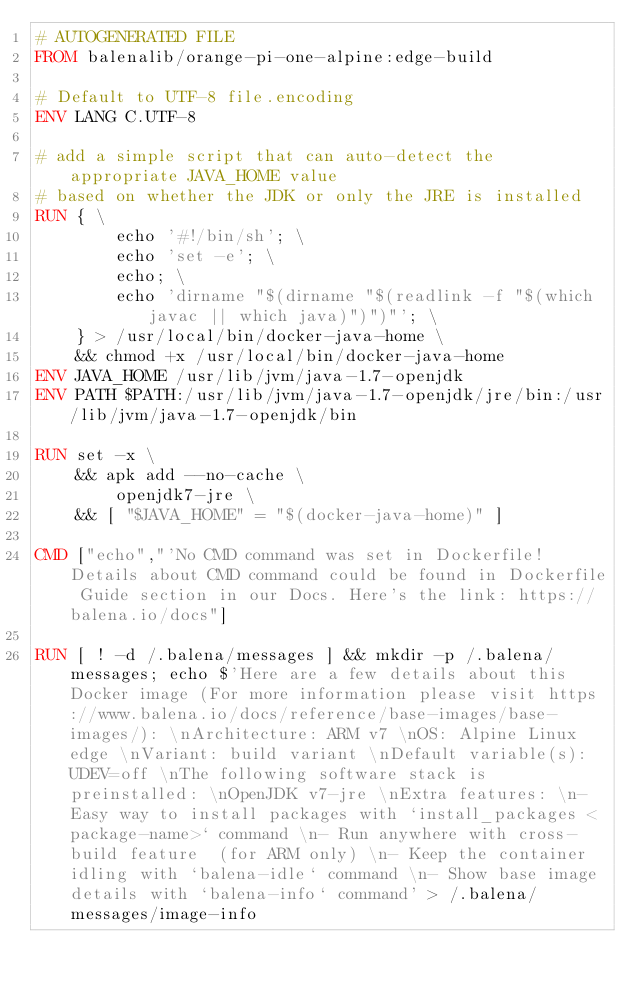Convert code to text. <code><loc_0><loc_0><loc_500><loc_500><_Dockerfile_># AUTOGENERATED FILE
FROM balenalib/orange-pi-one-alpine:edge-build

# Default to UTF-8 file.encoding
ENV LANG C.UTF-8

# add a simple script that can auto-detect the appropriate JAVA_HOME value
# based on whether the JDK or only the JRE is installed
RUN { \
		echo '#!/bin/sh'; \
		echo 'set -e'; \
		echo; \
		echo 'dirname "$(dirname "$(readlink -f "$(which javac || which java)")")"'; \
	} > /usr/local/bin/docker-java-home \
	&& chmod +x /usr/local/bin/docker-java-home
ENV JAVA_HOME /usr/lib/jvm/java-1.7-openjdk
ENV PATH $PATH:/usr/lib/jvm/java-1.7-openjdk/jre/bin:/usr/lib/jvm/java-1.7-openjdk/bin

RUN set -x \
	&& apk add --no-cache \
		openjdk7-jre \
	&& [ "$JAVA_HOME" = "$(docker-java-home)" ]

CMD ["echo","'No CMD command was set in Dockerfile! Details about CMD command could be found in Dockerfile Guide section in our Docs. Here's the link: https://balena.io/docs"]

RUN [ ! -d /.balena/messages ] && mkdir -p /.balena/messages; echo $'Here are a few details about this Docker image (For more information please visit https://www.balena.io/docs/reference/base-images/base-images/): \nArchitecture: ARM v7 \nOS: Alpine Linux edge \nVariant: build variant \nDefault variable(s): UDEV=off \nThe following software stack is preinstalled: \nOpenJDK v7-jre \nExtra features: \n- Easy way to install packages with `install_packages <package-name>` command \n- Run anywhere with cross-build feature  (for ARM only) \n- Keep the container idling with `balena-idle` command \n- Show base image details with `balena-info` command' > /.balena/messages/image-info</code> 